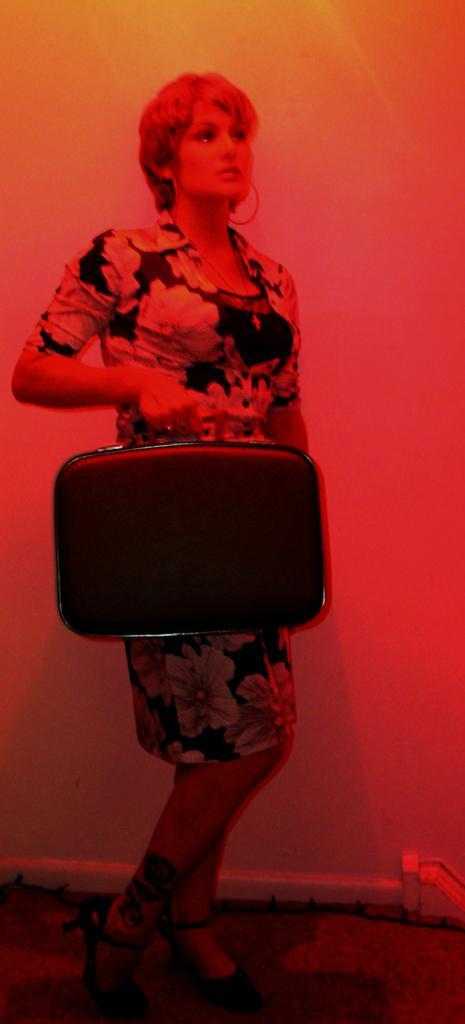What is present in the image? There is a person in the image. What is the person holding? The person is holding a bag. How many secretaries are present in the image? There is no mention of a secretary in the image, so it is not possible to determine the number of secretaries present. 